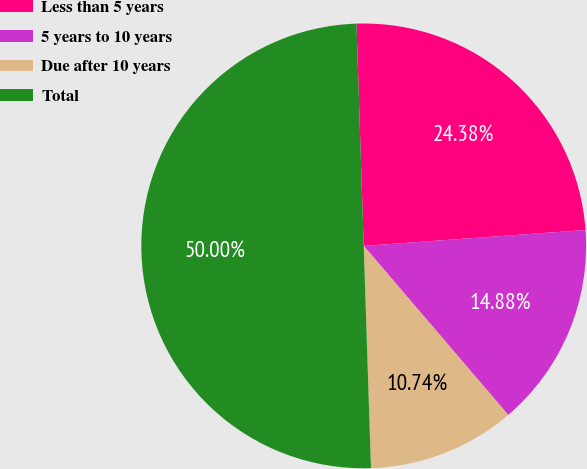Convert chart to OTSL. <chart><loc_0><loc_0><loc_500><loc_500><pie_chart><fcel>Less than 5 years<fcel>5 years to 10 years<fcel>Due after 10 years<fcel>Total<nl><fcel>24.38%<fcel>14.88%<fcel>10.74%<fcel>50.0%<nl></chart> 